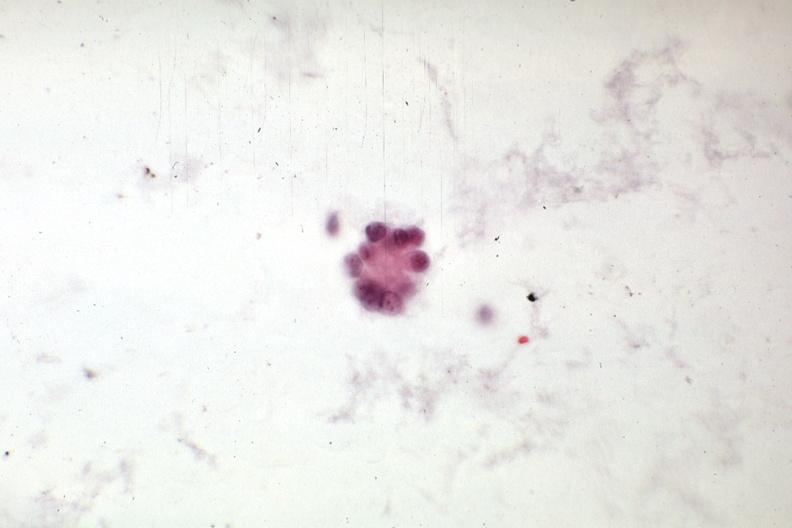s mesentery present?
Answer the question using a single word or phrase. No 